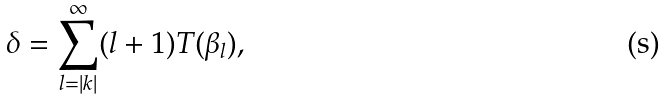<formula> <loc_0><loc_0><loc_500><loc_500>\delta = \sum _ { l = | k | } ^ { \infty } ( l + 1 ) T ( \beta _ { l } ) ,</formula> 